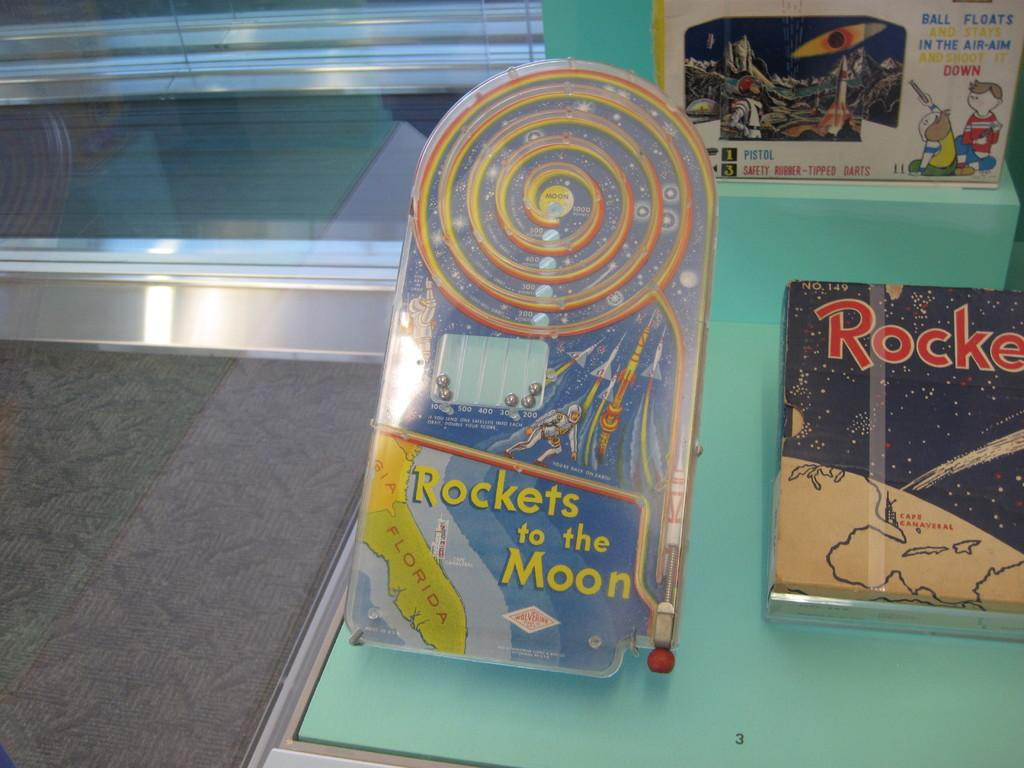<image>
Summarize the visual content of the image. A children's toy called Rockets to the Moon 